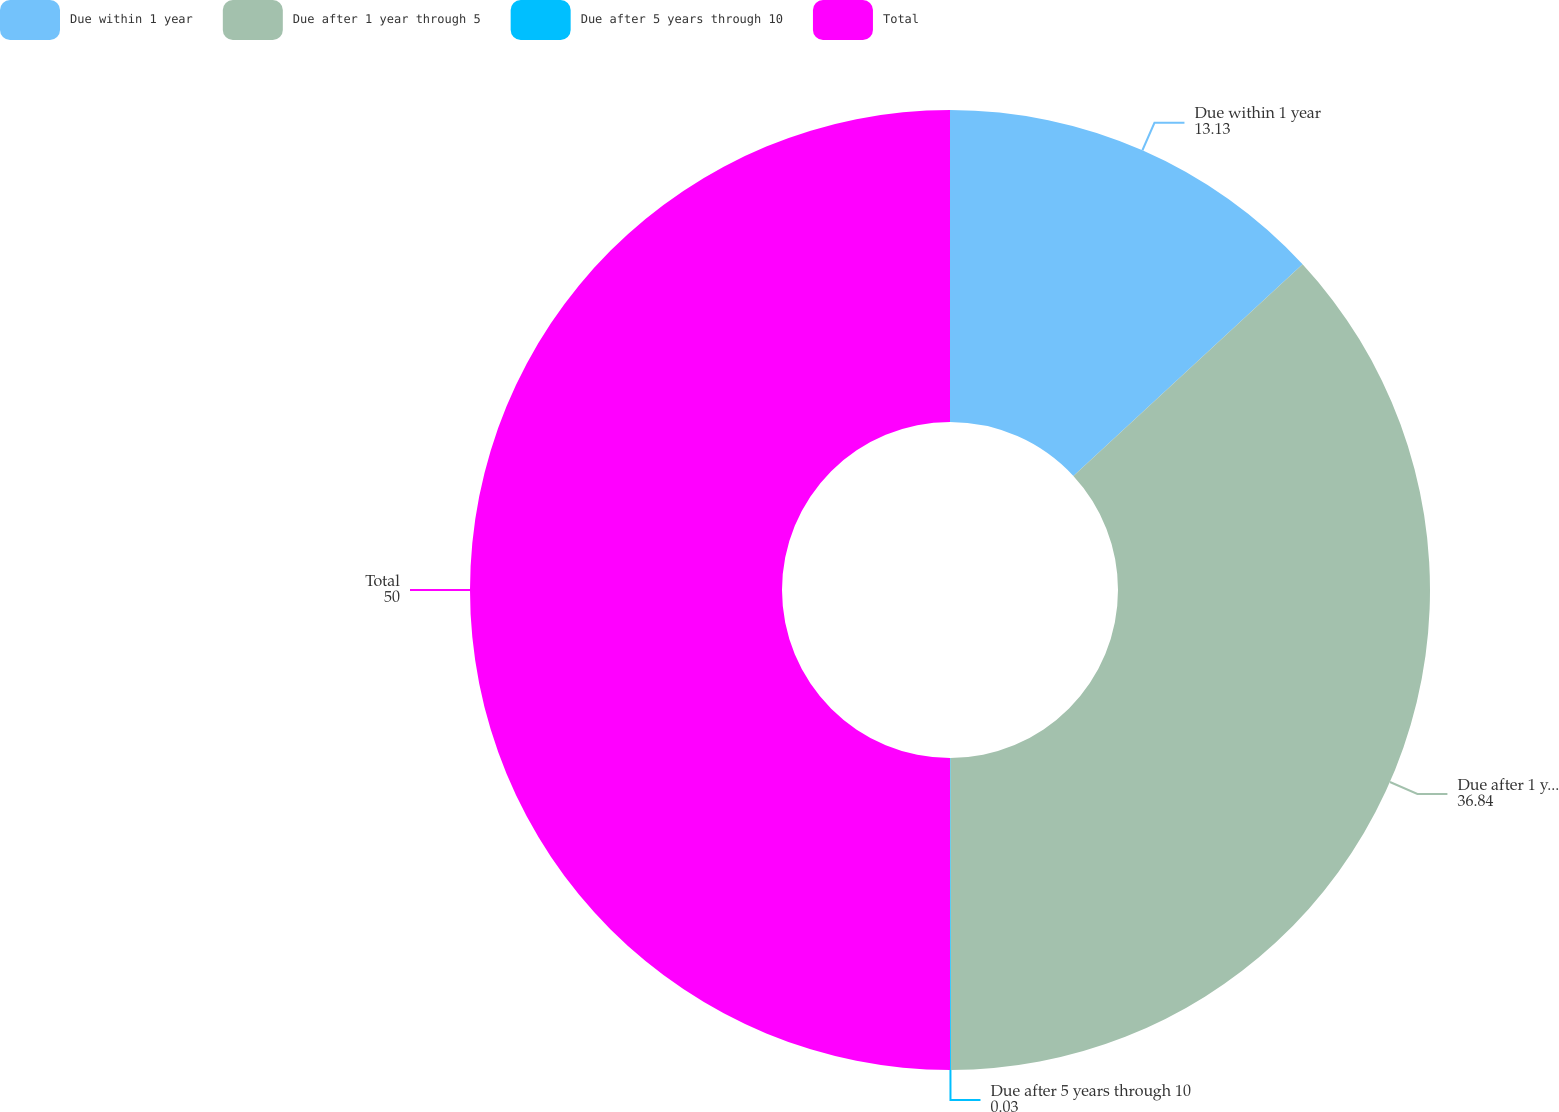Convert chart to OTSL. <chart><loc_0><loc_0><loc_500><loc_500><pie_chart><fcel>Due within 1 year<fcel>Due after 1 year through 5<fcel>Due after 5 years through 10<fcel>Total<nl><fcel>13.13%<fcel>36.84%<fcel>0.03%<fcel>50.0%<nl></chart> 